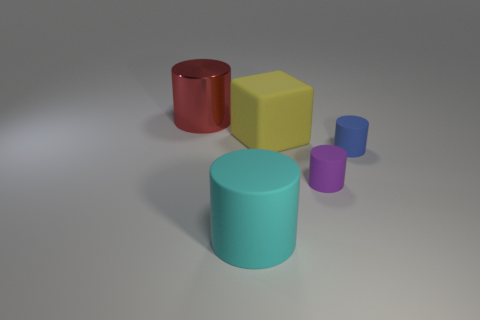Subtract 1 cylinders. How many cylinders are left? 3 Add 1 brown metal cubes. How many objects exist? 6 Subtract all cylinders. How many objects are left? 1 Add 5 blue things. How many blue things exist? 6 Subtract 0 cyan balls. How many objects are left? 5 Subtract all big yellow matte things. Subtract all large red metallic cylinders. How many objects are left? 3 Add 1 yellow blocks. How many yellow blocks are left? 2 